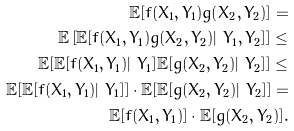<formula> <loc_0><loc_0><loc_500><loc_500>\mathbb { E } [ f ( X _ { 1 } , Y _ { 1 } ) g ( X _ { 2 } , Y _ { 2 } ) ] = \\ \mathbb { E } \left [ \mathbb { E } [ f ( X _ { 1 } , Y _ { 1 } ) g ( X _ { 2 } , Y _ { 2 } ) | \ Y _ { 1 } , Y _ { 2 } ] \right ] \leq \\ \mathbb { E } [ \mathbb { E } [ f ( X _ { 1 } , Y _ { 1 } ) | \ Y _ { 1 } ] \mathbb { E } [ g ( X _ { 2 } , Y _ { 2 } ) | \ Y _ { 2 } ] ] \leq \\ \mathbb { E } [ \mathbb { E } [ f ( X _ { 1 } , Y _ { 1 } ) | \ Y _ { 1 } ] ] \cdot \mathbb { E } [ \mathbb { E } [ g ( X _ { 2 } , Y _ { 2 } ) | \ Y _ { 2 } ] ] = \\ \mathbb { E } [ f ( X _ { 1 } , Y _ { 1 } ) ] \cdot \mathbb { E } [ g ( X _ { 2 } , Y _ { 2 } ) ] .</formula> 